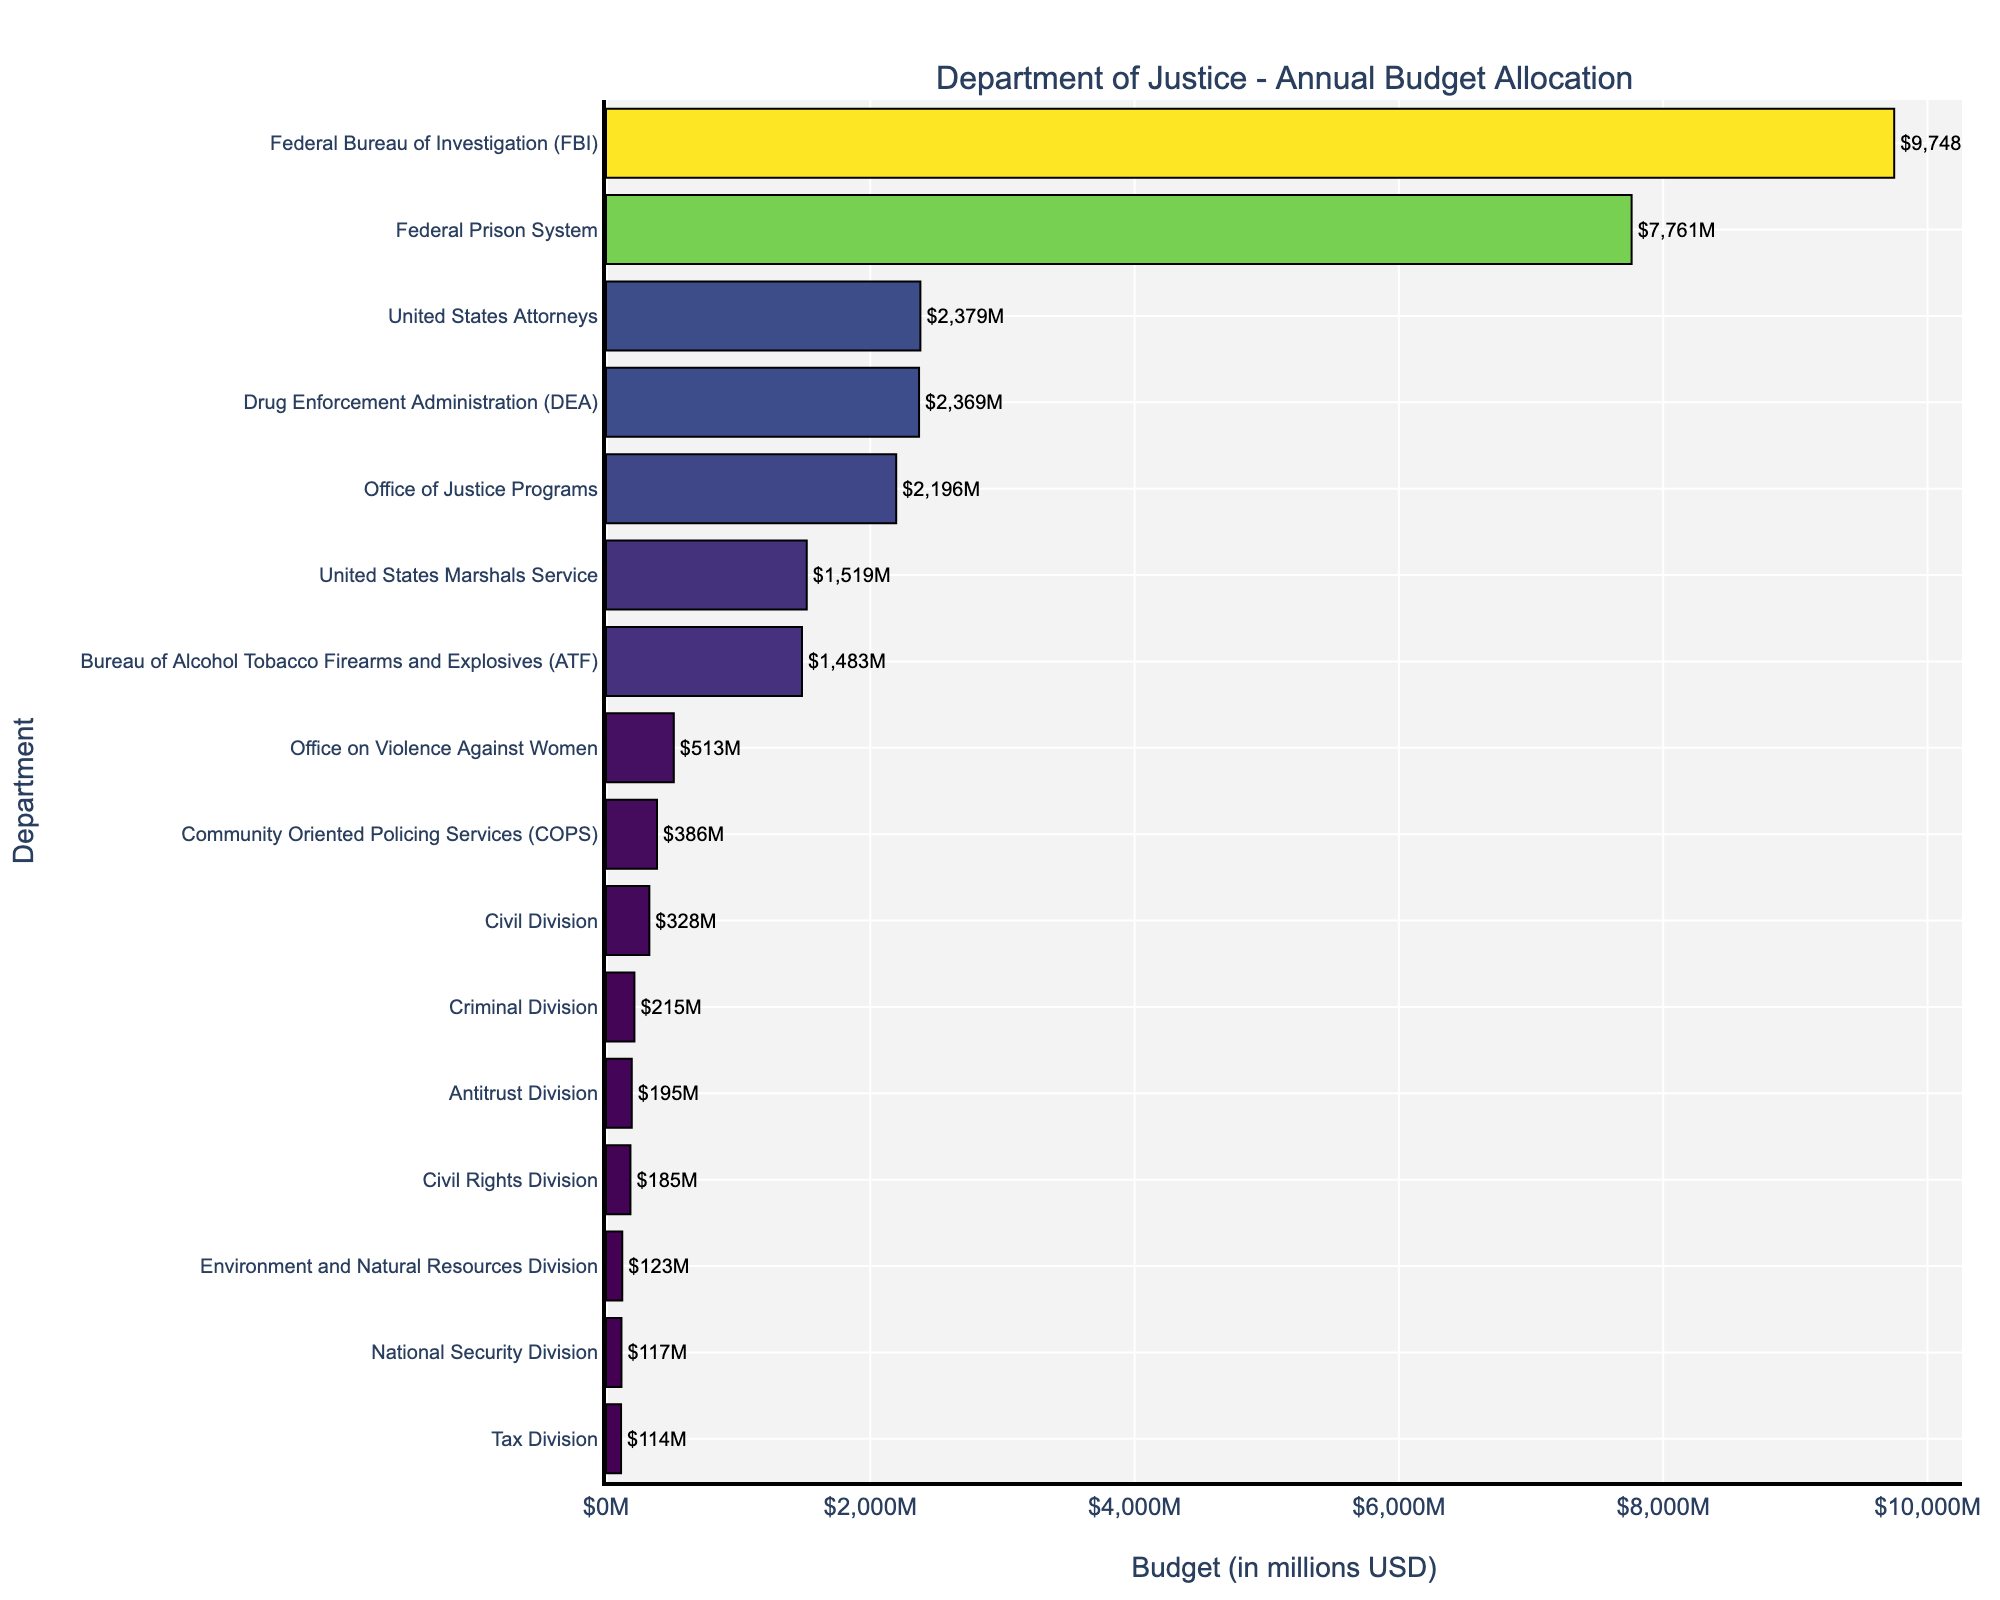Which department has the highest budget allocation? The figure shows that the Federal Bureau of Investigation (FBI) has the highest budget allocation, as its bar is the longest and has the highest value labeled.
Answer: Federal Bureau of Investigation (FBI) What is the combined budget of the departments with the smallest three allocations? The three departments with the smallest budgets are the Environment and Natural Resources Division ($123M), the Tax Division ($114M), and the National Security Division ($117M). Adding them together gives $123M + $114M + $117M = $354M.
Answer: $354M How much more is allocated to the FBI compared to the DEA? The budget for the FBI is $9,748M, and the budget for the DEA is $2,369M. The difference is $9,748M - $2,369M = $7,379M.
Answer: $7,379M Which department is allocated a budget of $513M, and where does it rank in terms of budget size? The Office on Violence Against Women is allocated $513M. In the sorted bar chart, it ranks 10th in terms of budget size.
Answer: Office on Violence Against Women, 10th What is the median budget allocation among all the departments? To find the median, list all the departments' budgets in ascending order. The median is the middle value in the ordered list. With 16 departments, the median is the average of the 8th and 9th values: the Civil Division ($328M) and the Community Oriented Policing Services (COPS) ($386M). The median is ($328M + $386M) / 2 = $357M.
Answer: $357M How does the budget of the Office of Justice Programs compare to that of the United States Attorneys? The Office of Justice Programs has a budget of $2,196M, while the United States Attorneys have $2,379M. The United States Attorneys' budget is slightly higher.
Answer: United States Attorneys > Office of Justice Programs Which department has a budget closest to $1,500M? The United States Marshals Service has a budget of $1,519M, which is the closest to $1,500M.
Answer: United States Marshals Service Identify three departments with budgets exceeding $5,000M and state their combined budget. The three departments are the Federal Bureau of Investigation ($9,748M), the Federal Prison System ($7,761M), and there is no third department exceeding $5,000M. Their combined budget is $9,748M + $7,761M = $17,509M.
Answer: $17,509M Are there more departments with budgets above or below $1,000M? There are 8 departments with budgets above $1,000M and 8 departments with budgets below $1,000M, so they are equal.
Answer: Equal Which department, adjacent to the Civil Rights Division in the sorted list, has a higher budget? Civil Rights Division has a budget of $185M. The adjacent departments in the sorted list are the Tax Division ($114M) below and the Antitrust Division ($195M) above. The Antitrust Division has a higher budget.
Answer: Antitrust Division 